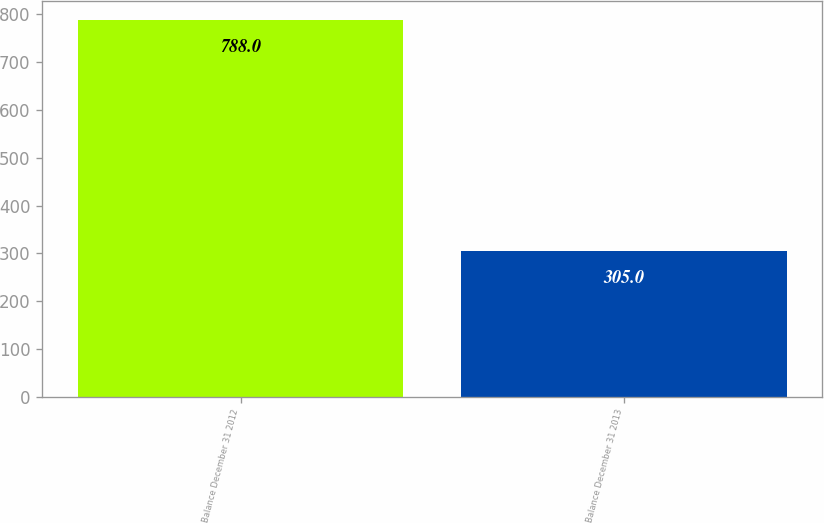<chart> <loc_0><loc_0><loc_500><loc_500><bar_chart><fcel>Balance December 31 2012<fcel>Balance December 31 2013<nl><fcel>788<fcel>305<nl></chart> 